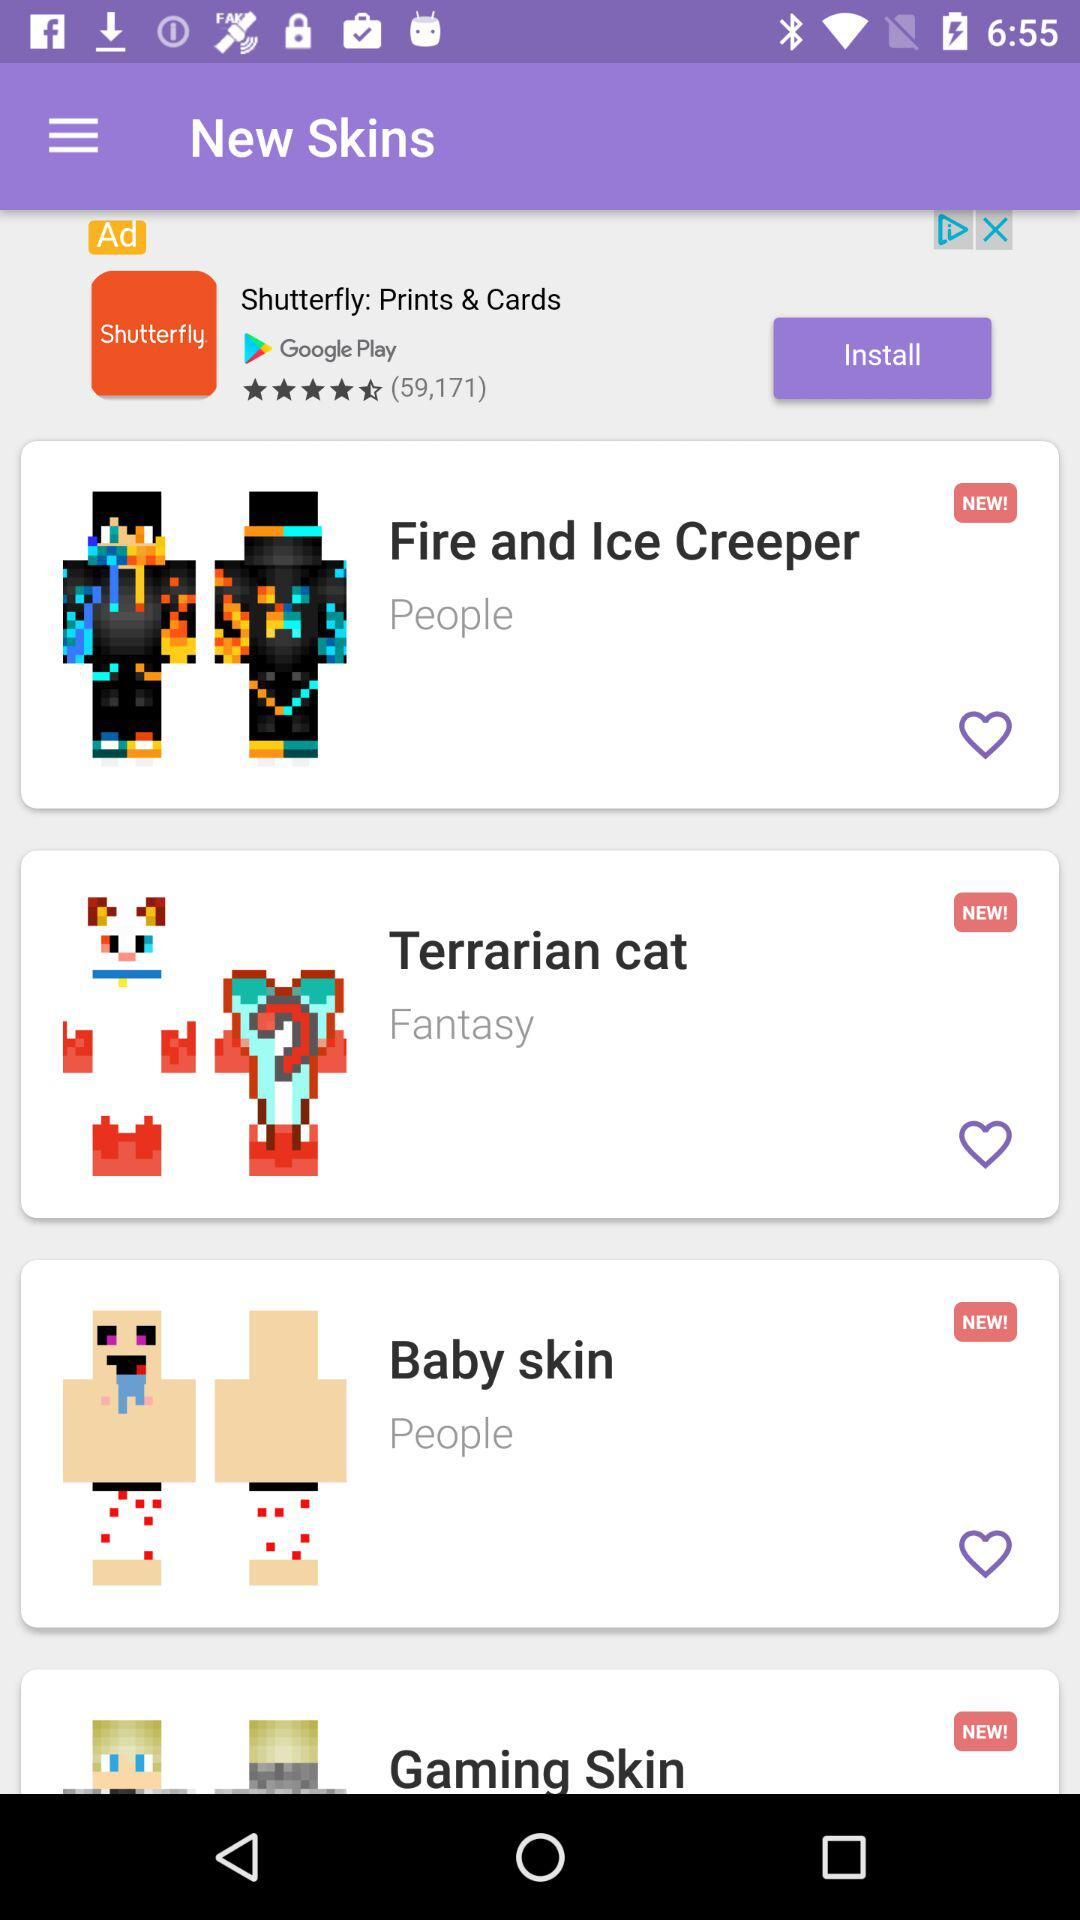To which category does "Gaming Skin" belong?
When the provided information is insufficient, respond with <no answer>. <no answer> 